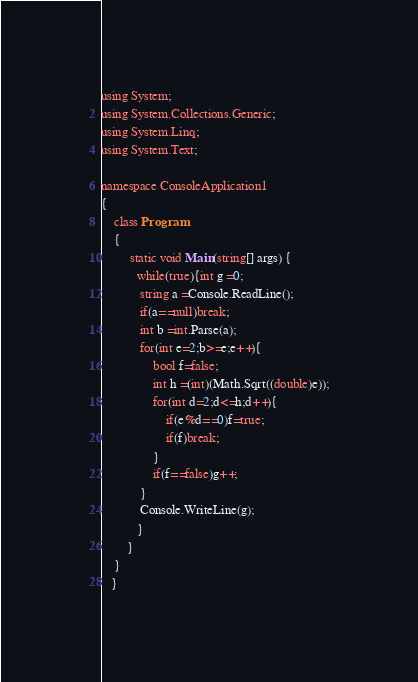<code> <loc_0><loc_0><loc_500><loc_500><_C#_>using System;
using System.Collections.Generic;
using System.Linq;
using System.Text;
 
namespace ConsoleApplication1
{   
    class Program
    {
         static void Main(string[] args) {
           while(true){int g =0;
           	string a =Console.ReadLine();
           	if(a==null)break;
           	int b =int.Parse(a);
           	for(int e=2;b>=e;e++){
           		bool f=false;
           		int h =(int)(Math.Sqrt((double)e));
           		for(int d=2;d<=h;d++){	
           			if(e%d==0)f=true;
           			if(f)break;
           		}
           		if(f==false)g++;
           	}
           	Console.WriteLine(g);
           }
        }
    }
   }</code> 